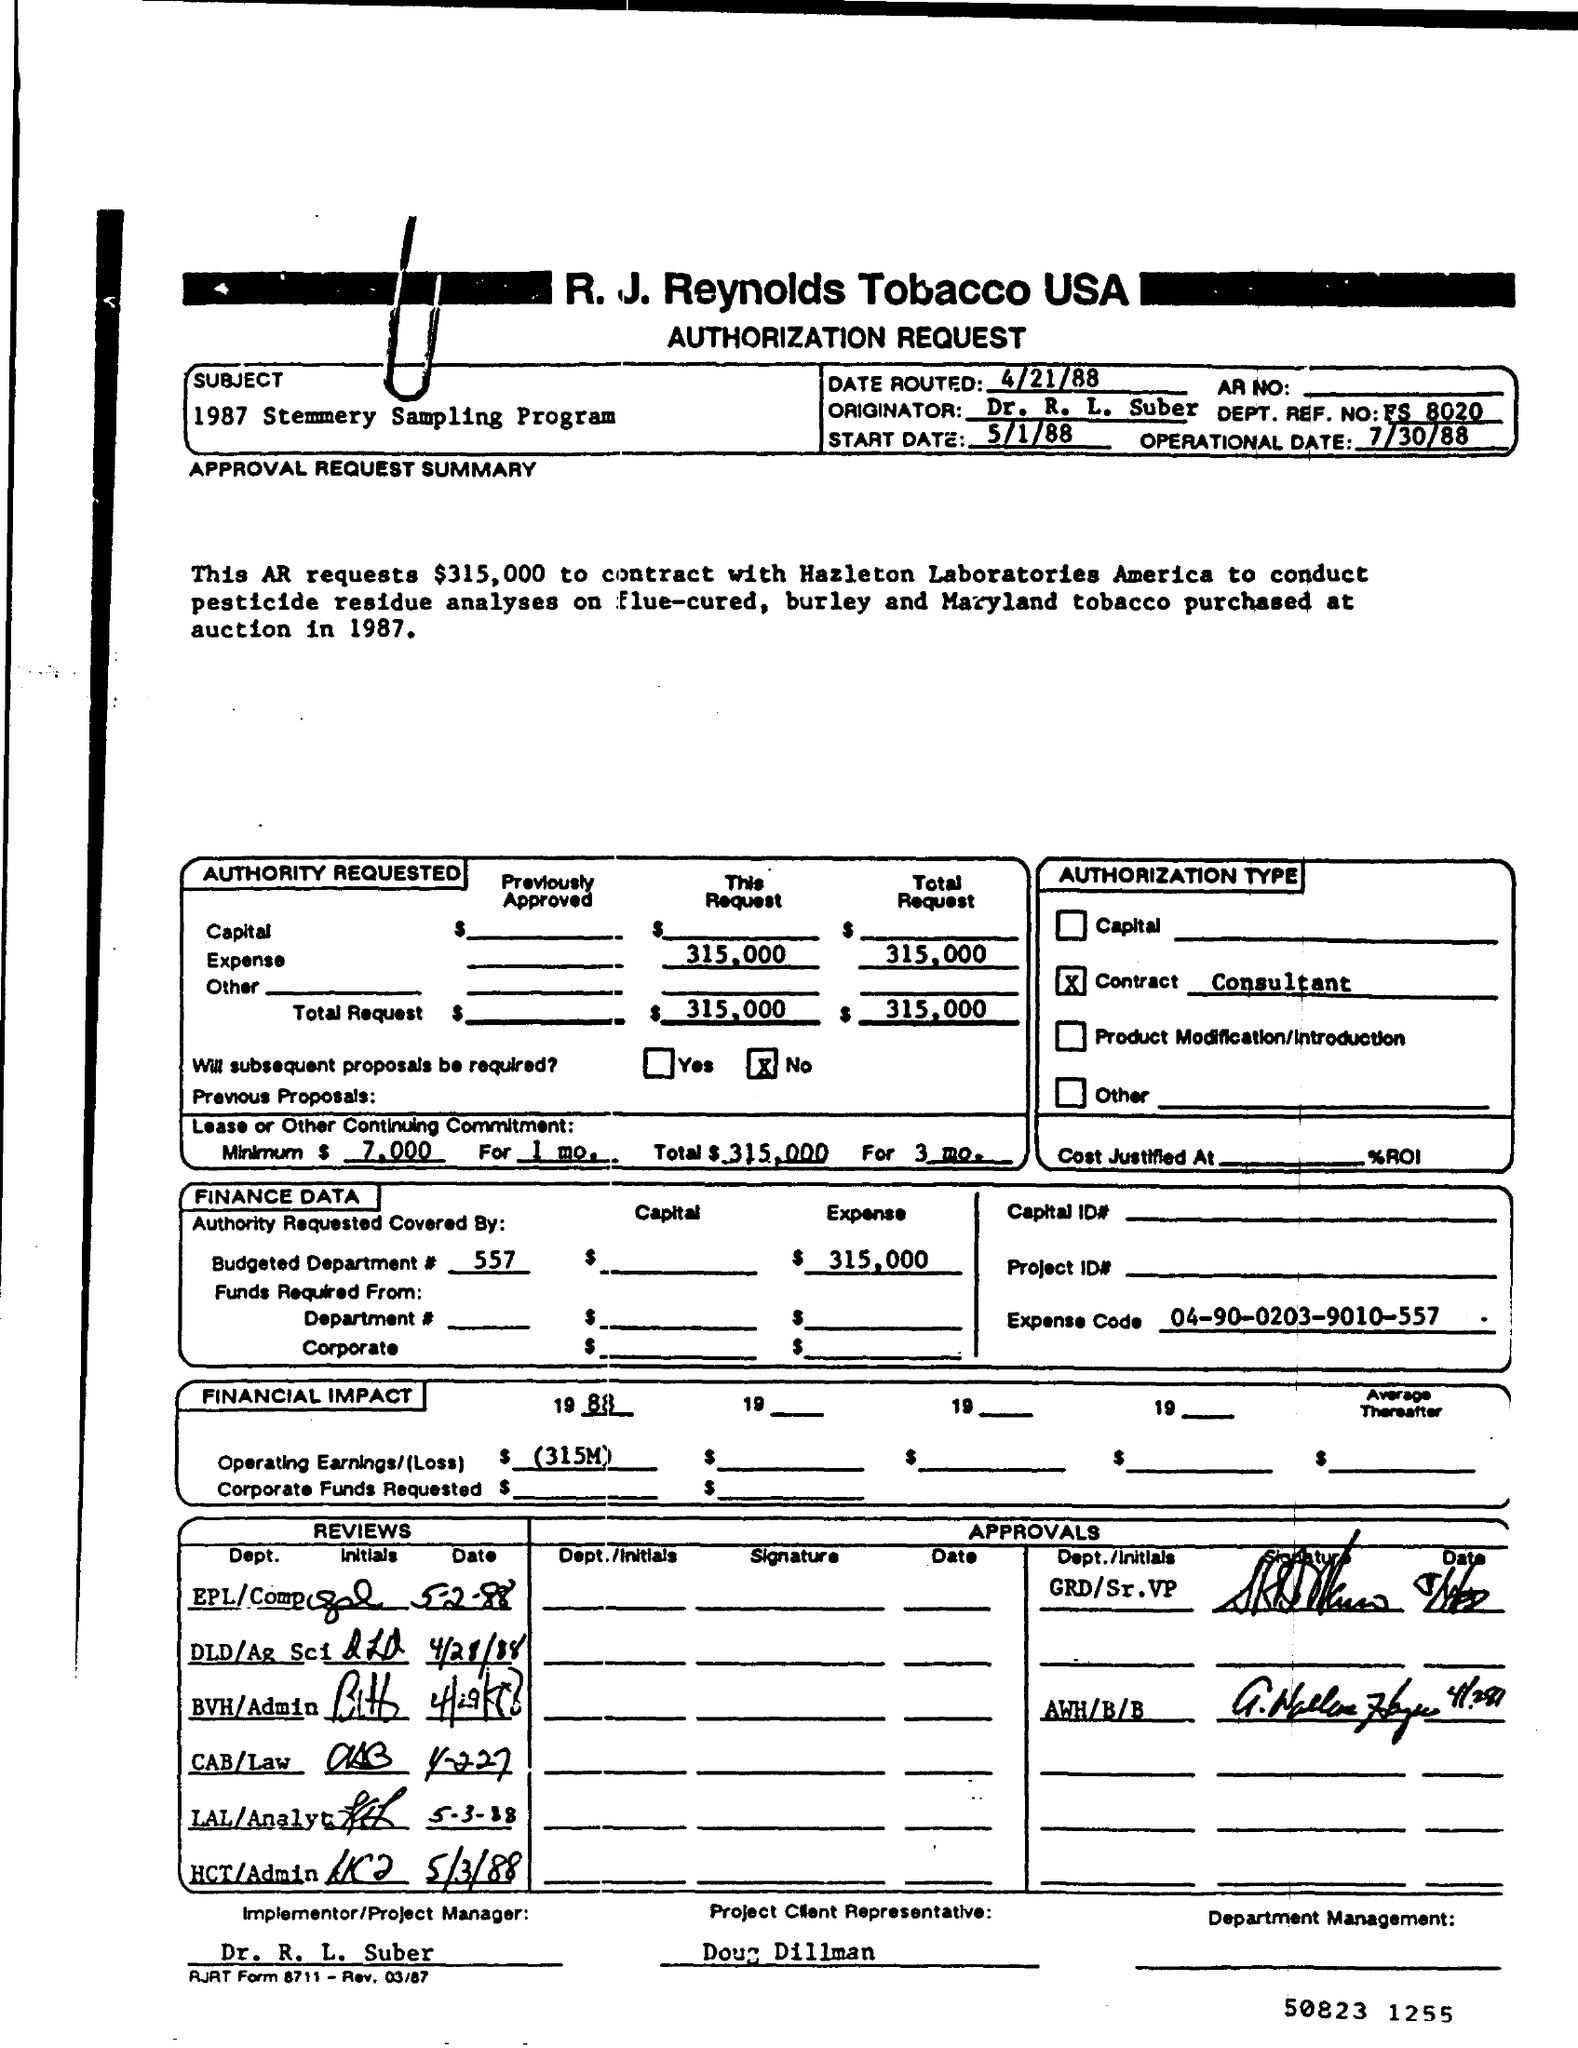What type of documentation is this?
Make the answer very short. Authorization Request. What is the subject?
Keep it short and to the point. 1987 stemmery sampling program. What is date routed?
Your response must be concise. 4/21/88. Who is the originator?
Offer a terse response. Dr. R. L. Suber. What is the DEPT. REF. NO?
Offer a terse response. FS 8020. What is the expense code?
Ensure brevity in your answer.  04-90-0203-9010-557. Who is the project client representative?
Ensure brevity in your answer.  Doug Dillman. 